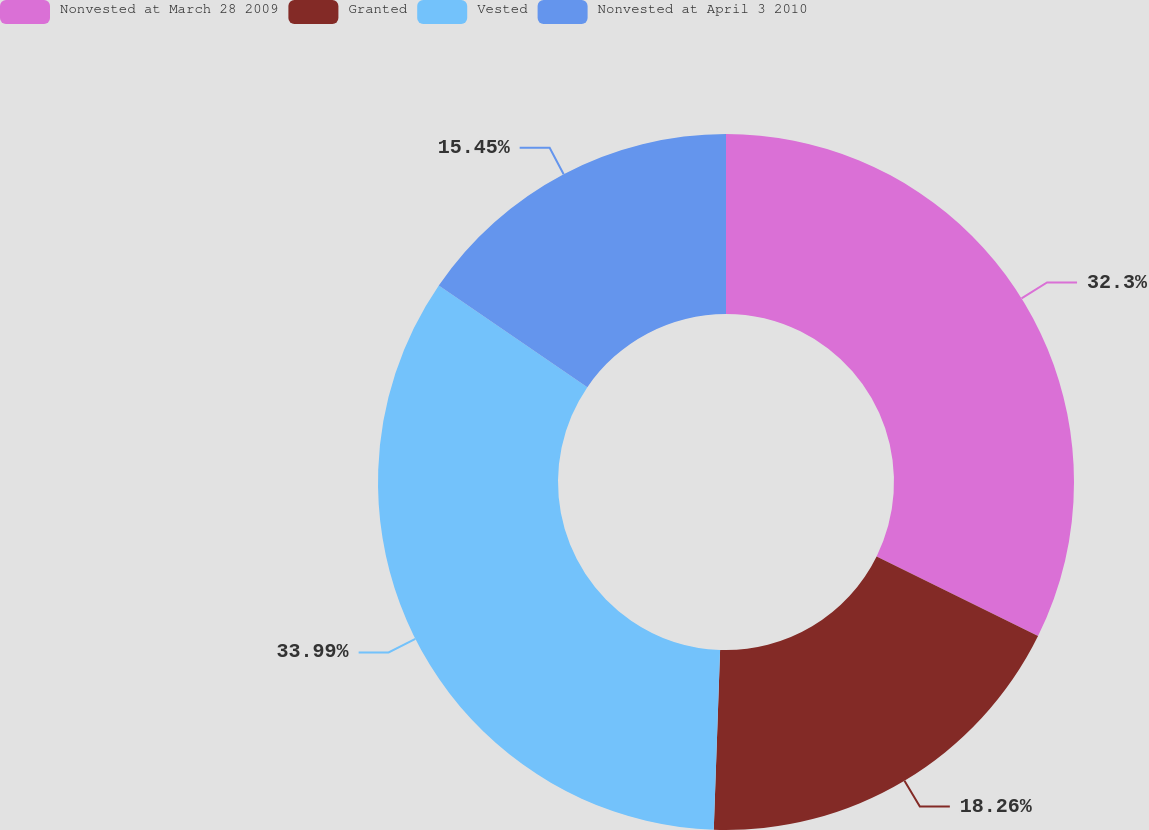Convert chart. <chart><loc_0><loc_0><loc_500><loc_500><pie_chart><fcel>Nonvested at March 28 2009<fcel>Granted<fcel>Vested<fcel>Nonvested at April 3 2010<nl><fcel>32.3%<fcel>18.26%<fcel>33.99%<fcel>15.45%<nl></chart> 